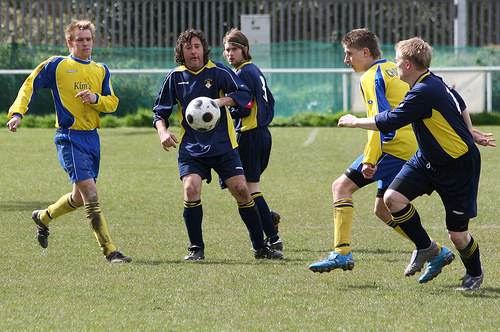<image>
Is there a man behind the ball? Yes. From this viewpoint, the man is positioned behind the ball, with the ball partially or fully occluding the man. Where is the foot ball in relation to the player? Is it in front of the player? No. The foot ball is not in front of the player. The spatial positioning shows a different relationship between these objects. 